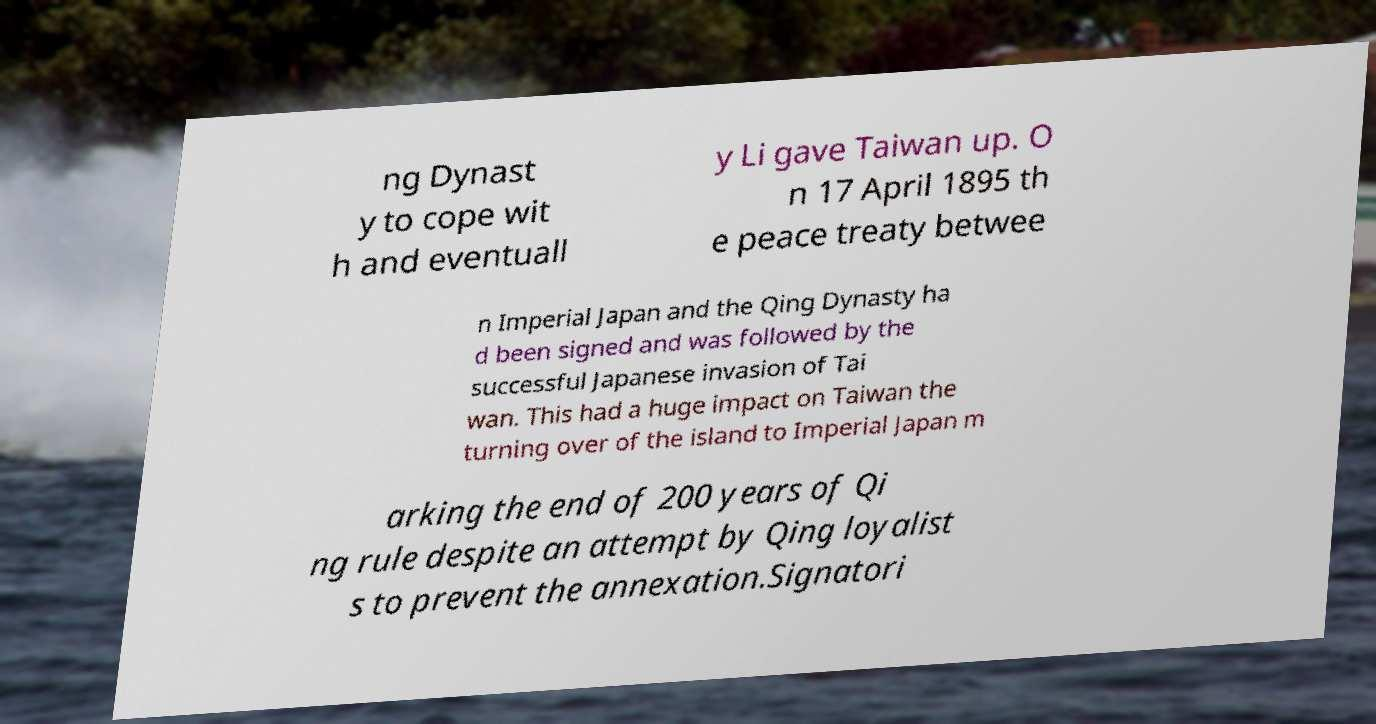There's text embedded in this image that I need extracted. Can you transcribe it verbatim? ng Dynast y to cope wit h and eventuall y Li gave Taiwan up. O n 17 April 1895 th e peace treaty betwee n Imperial Japan and the Qing Dynasty ha d been signed and was followed by the successful Japanese invasion of Tai wan. This had a huge impact on Taiwan the turning over of the island to Imperial Japan m arking the end of 200 years of Qi ng rule despite an attempt by Qing loyalist s to prevent the annexation.Signatori 